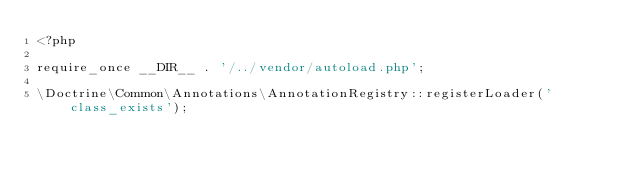<code> <loc_0><loc_0><loc_500><loc_500><_PHP_><?php

require_once __DIR__ . '/../vendor/autoload.php';

\Doctrine\Common\Annotations\AnnotationRegistry::registerLoader('class_exists');
</code> 